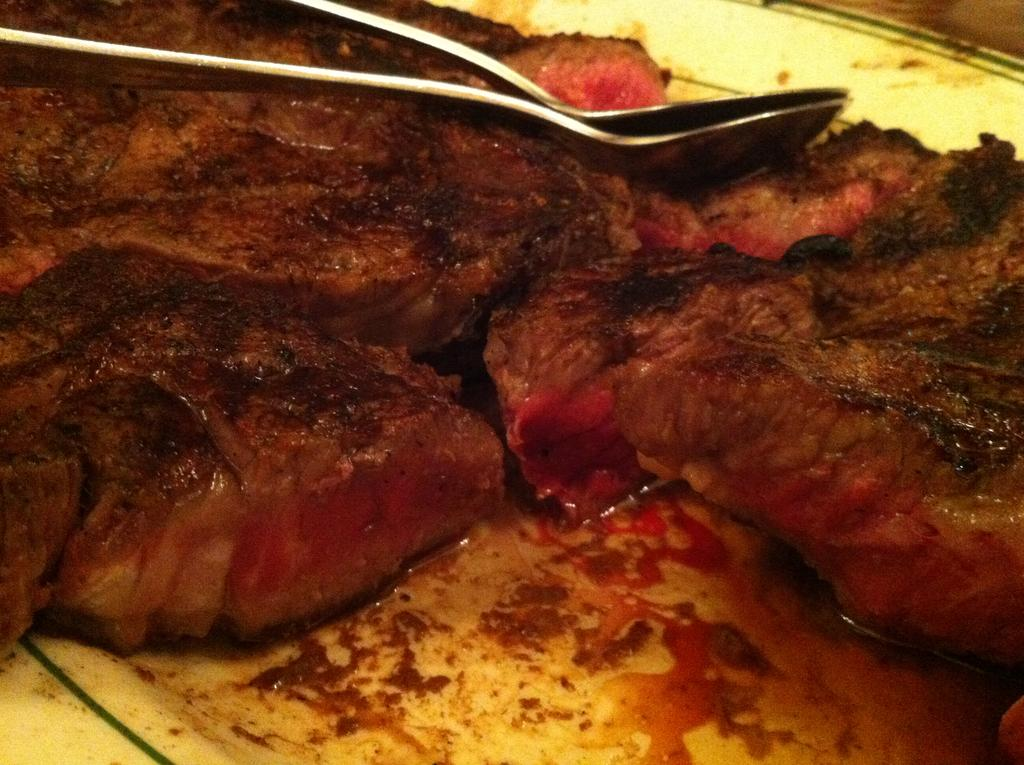What is present in the image related to eating? There is food and spoons in the image. Can you describe the type of food in the image? Unfortunately, the type of food is not specified in the provided facts. What utensils are visible in the image? Spoons are visible in the image. What type of party is being held in the image? There is no indication of a party in the image; it only shows food and spoons. Can you describe the apparatus used for cooking the food in the image? There is no apparatus used for cooking the food visible in the image. 